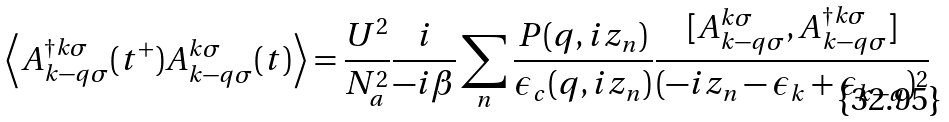Convert formula to latex. <formula><loc_0><loc_0><loc_500><loc_500>\left < A ^ { \dagger k \sigma } _ { k - q \sigma } ( t ^ { + } ) A ^ { k \sigma } _ { k - q \sigma } ( t ) \right > = \frac { U ^ { 2 } } { N ^ { 2 } _ { a } } \frac { i } { - i \beta } \sum _ { n } \frac { P ( q , i z _ { n } ) } { \epsilon _ { c } ( q , i z _ { n } ) } \frac { [ A _ { k - q \sigma } ^ { k \sigma } , A _ { k - q \sigma } ^ { \dagger k \sigma } ] } { ( - i z _ { n } - \epsilon _ { k } + \epsilon _ { k - q } ) ^ { 2 } }</formula> 